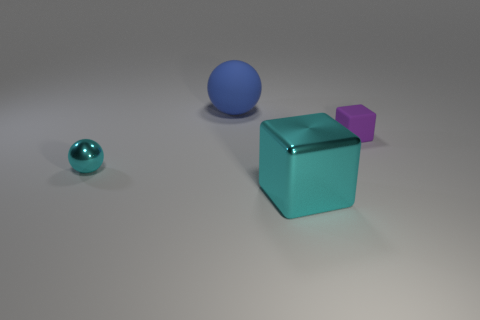What number of small balls are the same color as the large metal block?
Provide a succinct answer. 1. There is a large thing behind the small rubber thing; what shape is it?
Provide a succinct answer. Sphere. Is the block that is left of the purple matte object made of the same material as the big thing that is behind the purple cube?
Your response must be concise. No. What shape is the purple thing?
Provide a succinct answer. Cube. Are there an equal number of blue rubber objects to the right of the rubber block and rubber objects?
Ensure brevity in your answer.  No. There is a shiny cube that is the same color as the metallic ball; what size is it?
Ensure brevity in your answer.  Large. Are there any small purple objects made of the same material as the blue ball?
Make the answer very short. Yes. There is a matte object that is to the left of the purple cube; does it have the same shape as the tiny object in front of the purple matte block?
Ensure brevity in your answer.  Yes. Are there any small metallic objects?
Your answer should be compact. Yes. The thing that is the same size as the purple matte cube is what color?
Ensure brevity in your answer.  Cyan. 